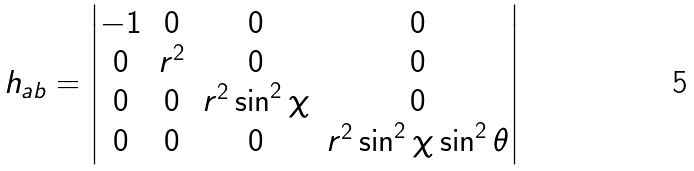<formula> <loc_0><loc_0><loc_500><loc_500>h _ { a b } = \begin{vmatrix} - 1 & 0 & 0 & 0 \\ 0 & r ^ { 2 } & 0 & 0 \\ 0 & 0 & r ^ { 2 } \sin ^ { 2 } \chi & 0 \\ 0 & 0 & 0 & r ^ { 2 } \sin ^ { 2 } \chi \sin ^ { 2 } \theta \end{vmatrix}</formula> 